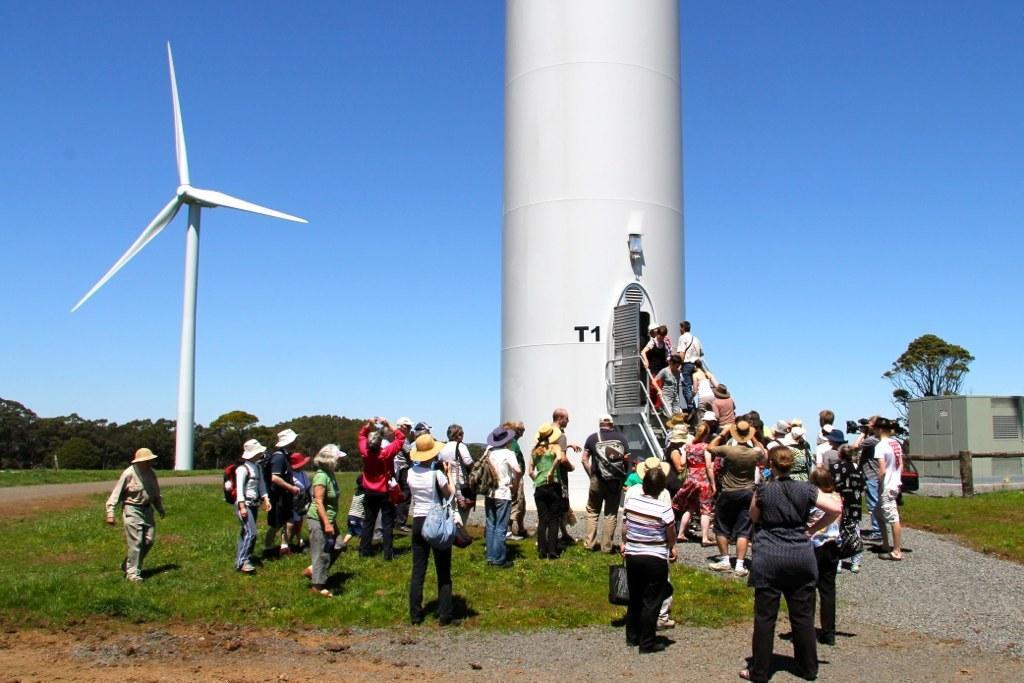Can you describe this image briefly? In this picture we can see windmills and group of people, few people wore caps, on the right side of the image we can see a house, in the background we can find few trees. 